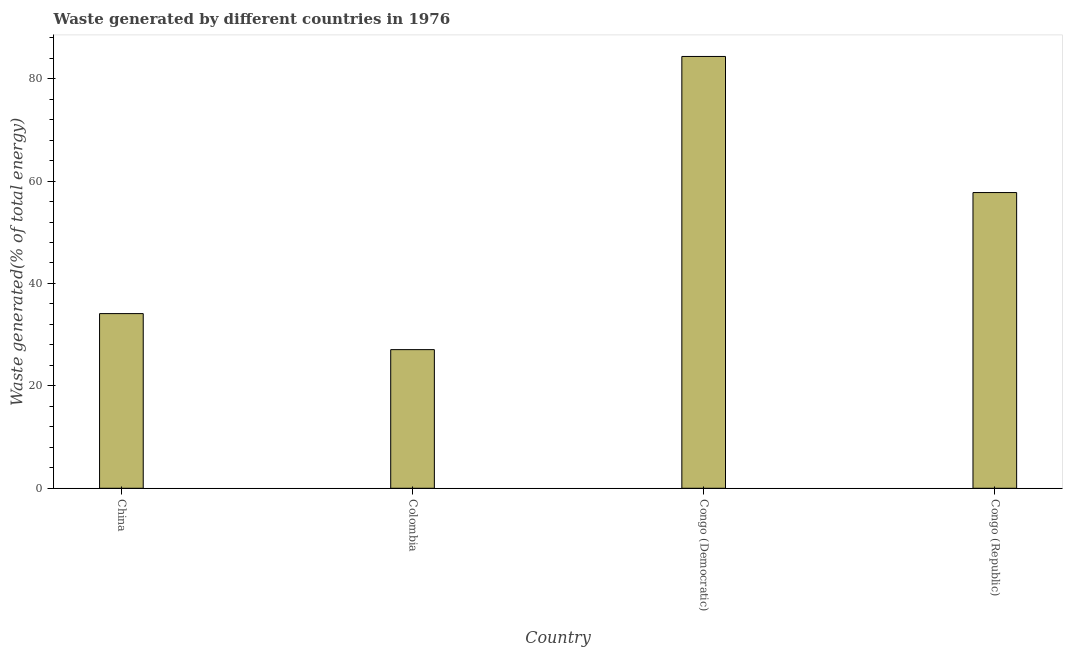Does the graph contain grids?
Ensure brevity in your answer.  No. What is the title of the graph?
Give a very brief answer. Waste generated by different countries in 1976. What is the label or title of the Y-axis?
Provide a short and direct response. Waste generated(% of total energy). What is the amount of waste generated in Congo (Republic)?
Make the answer very short. 57.75. Across all countries, what is the maximum amount of waste generated?
Make the answer very short. 84.33. Across all countries, what is the minimum amount of waste generated?
Your answer should be very brief. 27.08. In which country was the amount of waste generated maximum?
Give a very brief answer. Congo (Democratic). In which country was the amount of waste generated minimum?
Provide a short and direct response. Colombia. What is the sum of the amount of waste generated?
Provide a short and direct response. 203.26. What is the difference between the amount of waste generated in China and Congo (Democratic)?
Make the answer very short. -50.22. What is the average amount of waste generated per country?
Provide a short and direct response. 50.82. What is the median amount of waste generated?
Your response must be concise. 45.93. What is the ratio of the amount of waste generated in Congo (Democratic) to that in Congo (Republic)?
Give a very brief answer. 1.46. Is the amount of waste generated in China less than that in Congo (Democratic)?
Make the answer very short. Yes. Is the difference between the amount of waste generated in China and Colombia greater than the difference between any two countries?
Provide a short and direct response. No. What is the difference between the highest and the second highest amount of waste generated?
Offer a terse response. 26.58. Is the sum of the amount of waste generated in Colombia and Congo (Democratic) greater than the maximum amount of waste generated across all countries?
Your response must be concise. Yes. What is the difference between the highest and the lowest amount of waste generated?
Your response must be concise. 57.25. Are the values on the major ticks of Y-axis written in scientific E-notation?
Give a very brief answer. No. What is the Waste generated(% of total energy) of China?
Offer a very short reply. 34.11. What is the Waste generated(% of total energy) of Colombia?
Provide a short and direct response. 27.08. What is the Waste generated(% of total energy) in Congo (Democratic)?
Give a very brief answer. 84.33. What is the Waste generated(% of total energy) in Congo (Republic)?
Provide a short and direct response. 57.75. What is the difference between the Waste generated(% of total energy) in China and Colombia?
Ensure brevity in your answer.  7.04. What is the difference between the Waste generated(% of total energy) in China and Congo (Democratic)?
Your response must be concise. -50.22. What is the difference between the Waste generated(% of total energy) in China and Congo (Republic)?
Ensure brevity in your answer.  -23.64. What is the difference between the Waste generated(% of total energy) in Colombia and Congo (Democratic)?
Provide a short and direct response. -57.25. What is the difference between the Waste generated(% of total energy) in Colombia and Congo (Republic)?
Ensure brevity in your answer.  -30.67. What is the difference between the Waste generated(% of total energy) in Congo (Democratic) and Congo (Republic)?
Give a very brief answer. 26.58. What is the ratio of the Waste generated(% of total energy) in China to that in Colombia?
Your response must be concise. 1.26. What is the ratio of the Waste generated(% of total energy) in China to that in Congo (Democratic)?
Ensure brevity in your answer.  0.41. What is the ratio of the Waste generated(% of total energy) in China to that in Congo (Republic)?
Offer a terse response. 0.59. What is the ratio of the Waste generated(% of total energy) in Colombia to that in Congo (Democratic)?
Provide a short and direct response. 0.32. What is the ratio of the Waste generated(% of total energy) in Colombia to that in Congo (Republic)?
Offer a very short reply. 0.47. What is the ratio of the Waste generated(% of total energy) in Congo (Democratic) to that in Congo (Republic)?
Offer a terse response. 1.46. 